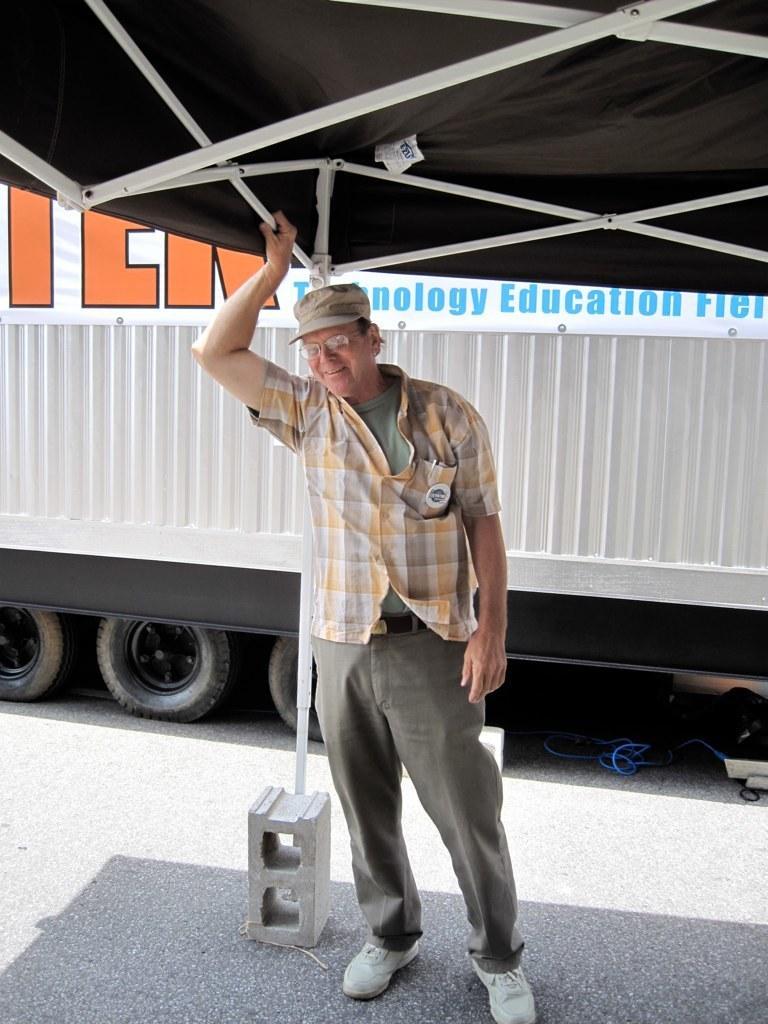Please provide a concise description of this image. In this image I can see the person standing and holding the rod. The person is wearing green and yellow color shirt. In the background I can see the vehicle in white color. 